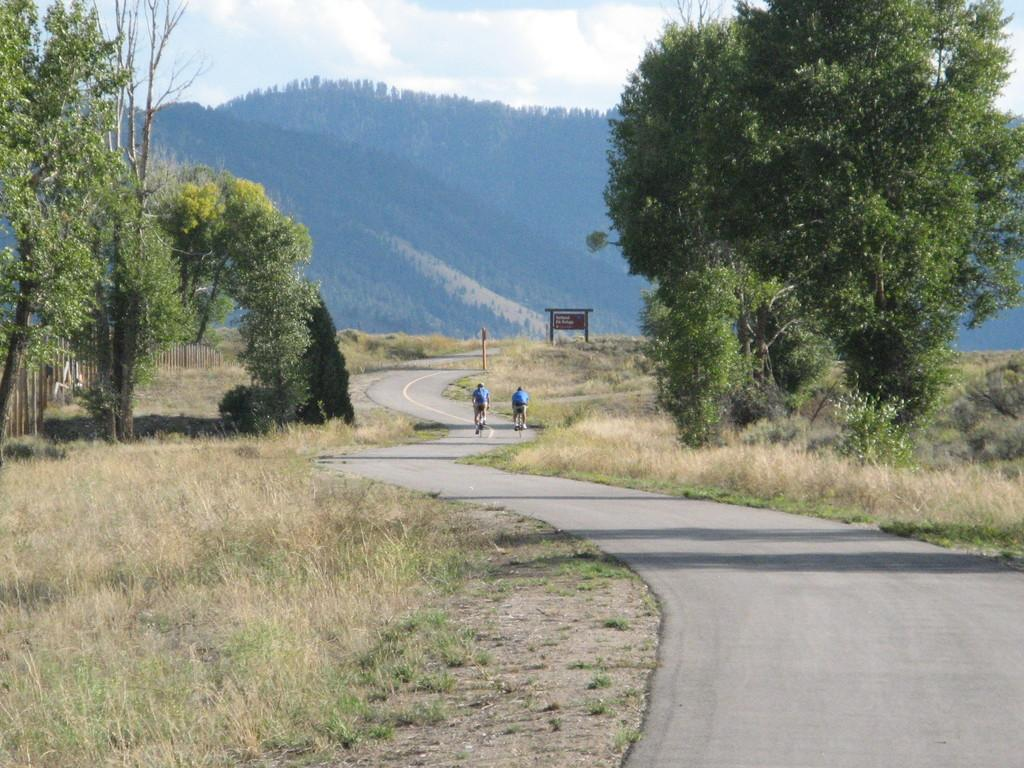How many people are in the image? There are people in the image, but the exact number is not specified. What are the people doing in the image? The people are riding bicycles in the image. Where are the bicycles located? The bicycles are on a road in the image. What can be seen in the background of the image? In the background of the image, there are trees, grass, hills, and a board. What type of book is the person reading while riding the bicycle in the image? There is no book present in the image; the people are riding bicycles, not reading books. 